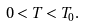Convert formula to latex. <formula><loc_0><loc_0><loc_500><loc_500>0 < T < T _ { 0 } .</formula> 